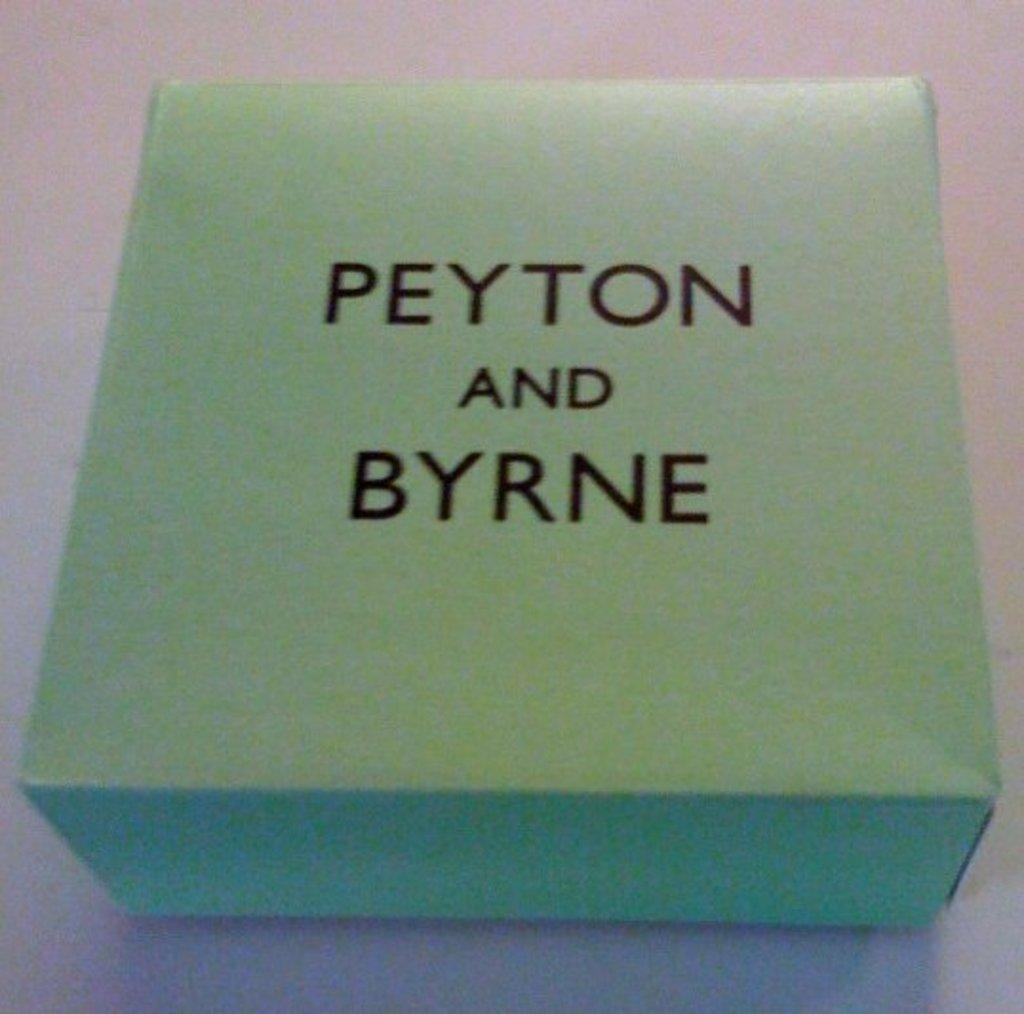<image>
Give a short and clear explanation of the subsequent image. the word peyton that is on a blue square item 